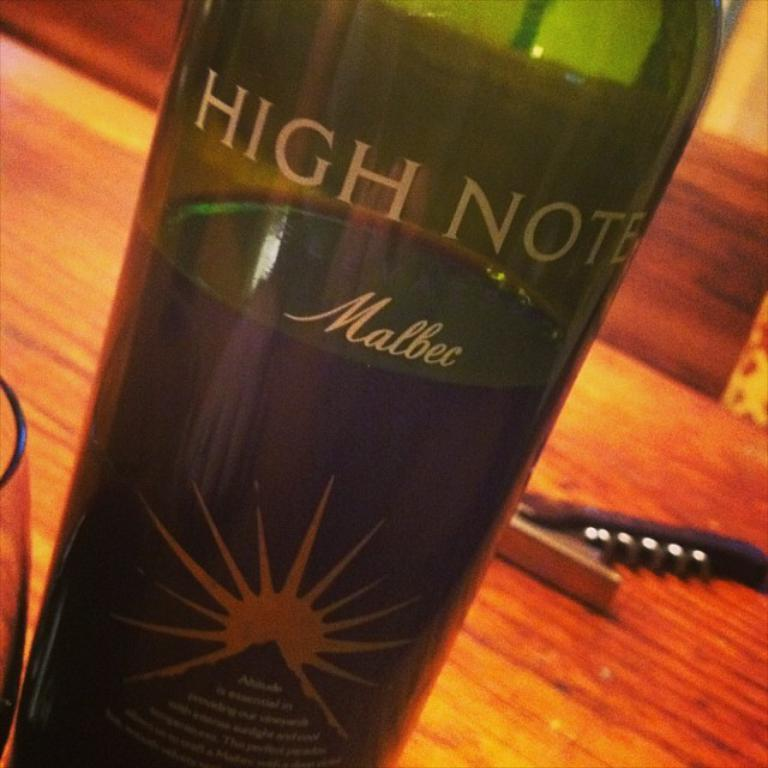<image>
Provide a brief description of the given image. The bottle of High Note Malbec wine sits 2/3 full on the table near the corkscrew. 